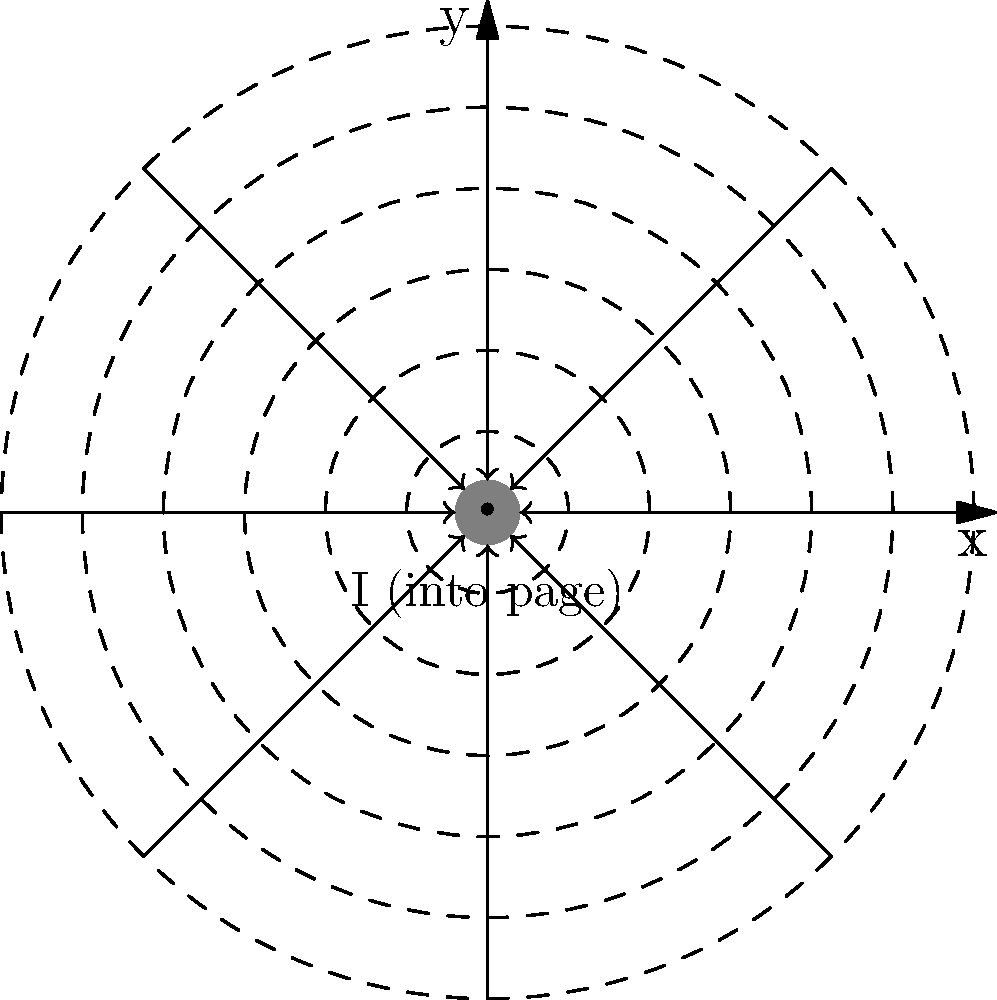As a software engineer who has worked on complex systems, you understand the importance of visualizing data. Consider a long, straight wire carrying a current I into the page, as shown in the cross-sectional view. The magnetic field lines are represented by concentric circles. If the current is doubled, how would the magnetic field strength at a point P, located at a distance r from the wire's center, change? Let's approach this step-by-step:

1. Recall Ampère's law for a long, straight wire: The magnetic field $B$ at a distance $r$ from the wire is given by:

   $$B = \frac{\mu_0 I}{2\pi r}$$

   Where $\mu_0$ is the permeability of free space, $I$ is the current, and $r$ is the distance from the wire.

2. Initially, let's say the current is $I$ and the magnetic field at point P is $B_1$:

   $$B_1 = \frac{\mu_0 I}{2\pi r}$$

3. When the current is doubled to $2I$, the new magnetic field $B_2$ becomes:

   $$B_2 = \frac{\mu_0 (2I)}{2\pi r} = \frac{2\mu_0 I}{2\pi r}$$

4. Comparing $B_2$ to $B_1$:

   $$B_2 = 2 \cdot \frac{\mu_0 I}{2\pi r} = 2B_1$$

5. This shows that doubling the current doubles the magnetic field strength at any given point.

As a software engineer, you can think of this as a linear scaling operation, where the input (current) has a direct, proportional effect on the output (magnetic field strength).
Answer: The magnetic field strength doubles. 